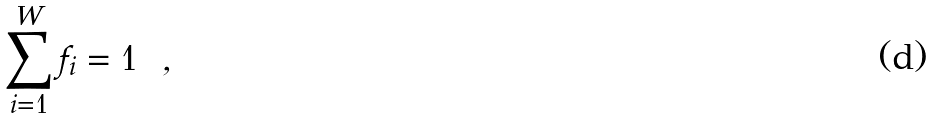<formula> <loc_0><loc_0><loc_500><loc_500>\sum _ { i = 1 } ^ { W } f _ { i } = 1 \ \ ,</formula> 